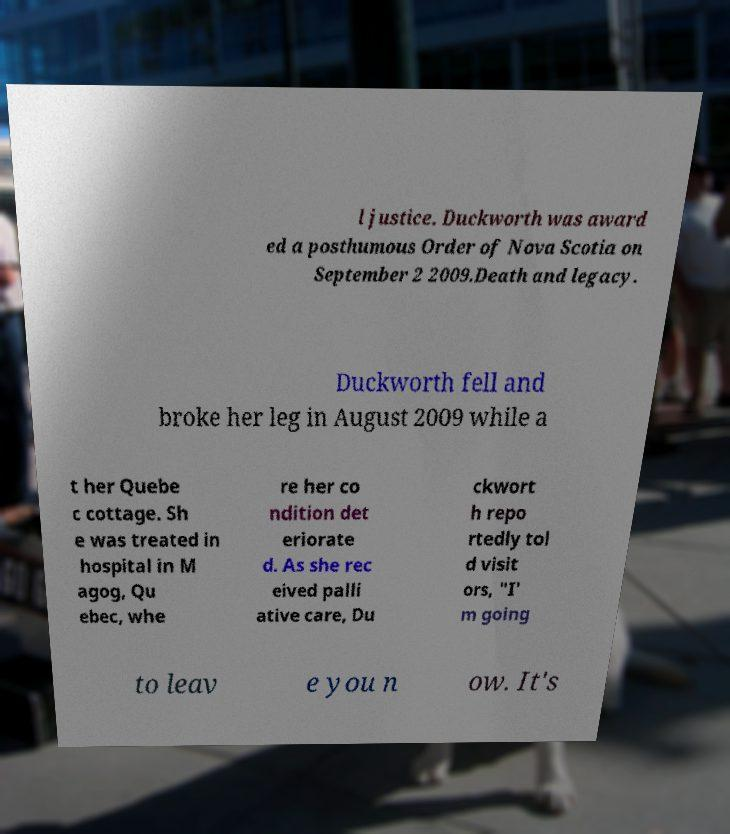Please identify and transcribe the text found in this image. l justice. Duckworth was award ed a posthumous Order of Nova Scotia on September 2 2009.Death and legacy. Duckworth fell and broke her leg in August 2009 while a t her Quebe c cottage. Sh e was treated in hospital in M agog, Qu ebec, whe re her co ndition det eriorate d. As she rec eived palli ative care, Du ckwort h repo rtedly tol d visit ors, "I' m going to leav e you n ow. It's 